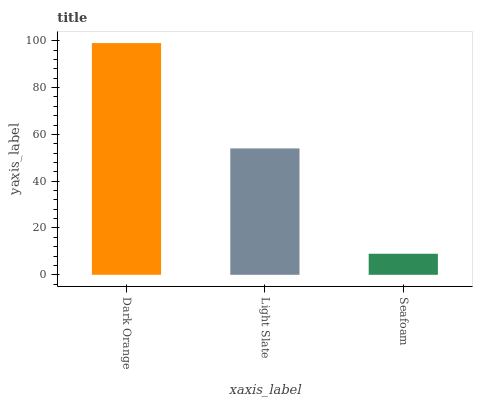Is Light Slate the minimum?
Answer yes or no. No. Is Light Slate the maximum?
Answer yes or no. No. Is Dark Orange greater than Light Slate?
Answer yes or no. Yes. Is Light Slate less than Dark Orange?
Answer yes or no. Yes. Is Light Slate greater than Dark Orange?
Answer yes or no. No. Is Dark Orange less than Light Slate?
Answer yes or no. No. Is Light Slate the high median?
Answer yes or no. Yes. Is Light Slate the low median?
Answer yes or no. Yes. Is Dark Orange the high median?
Answer yes or no. No. Is Seafoam the low median?
Answer yes or no. No. 